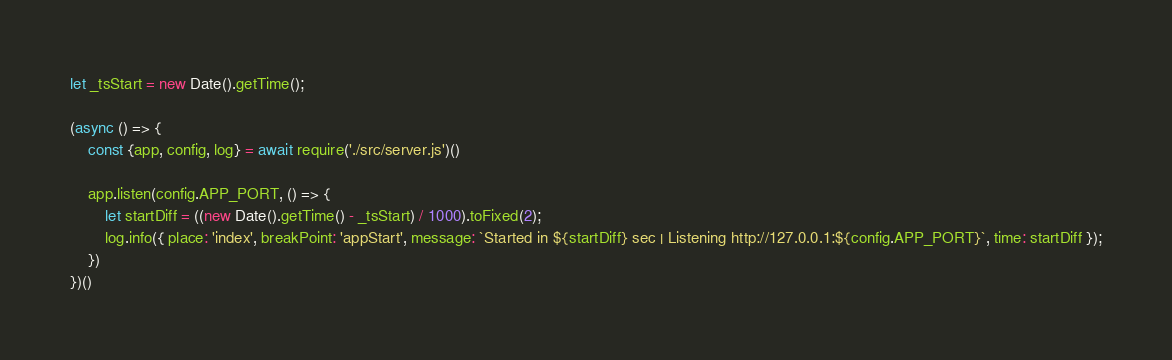Convert code to text. <code><loc_0><loc_0><loc_500><loc_500><_JavaScript_>let _tsStart = new Date().getTime();

(async () => {
	const {app, config, log} = await require('./src/server.js')()

	app.listen(config.APP_PORT, () => {
		let startDiff = ((new Date().getTime() - _tsStart) / 1000).toFixed(2);
		log.info({ place: 'index', breakPoint: 'appStart', message: `Started in ${startDiff} sec | Listening http://127.0.0.1:${config.APP_PORT}`, time: startDiff });
	})
})()</code> 